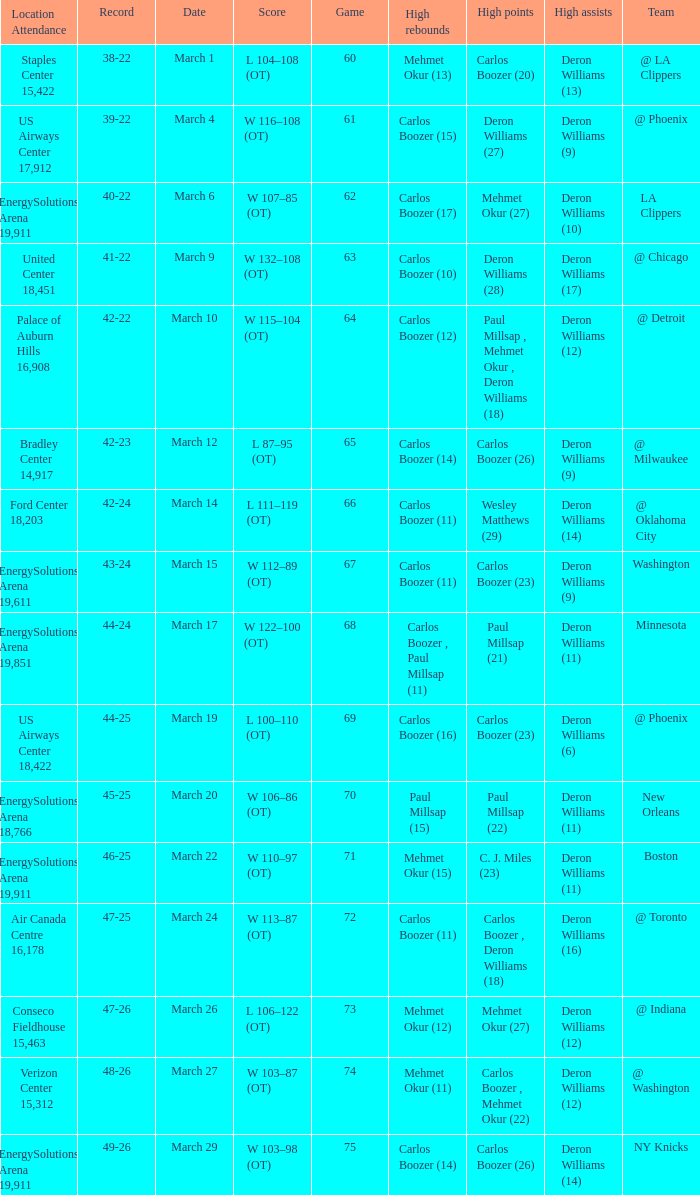Where was the March 24 game played? Air Canada Centre 16,178. 